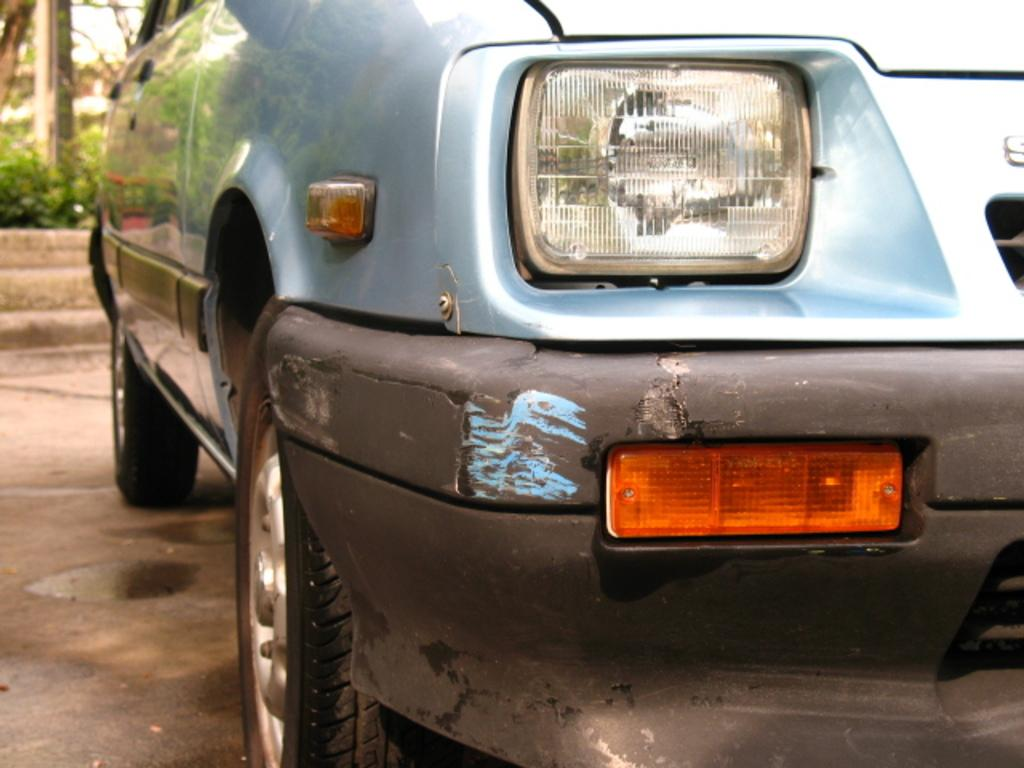What is the main subject of the image? The main subject of the image is a car. Where is the car located in the image? The car is on the road in the image. What can be seen in the background of the image? There are plants and trees in the background of the image. What type of pies can be seen in the image? There are no pies present in the image. What type of rice is being cooked in the image? There are no rice or cooking activities present in the image. What type of cherry is visible on the car in the image? There are no cherries present on the car in the image. 